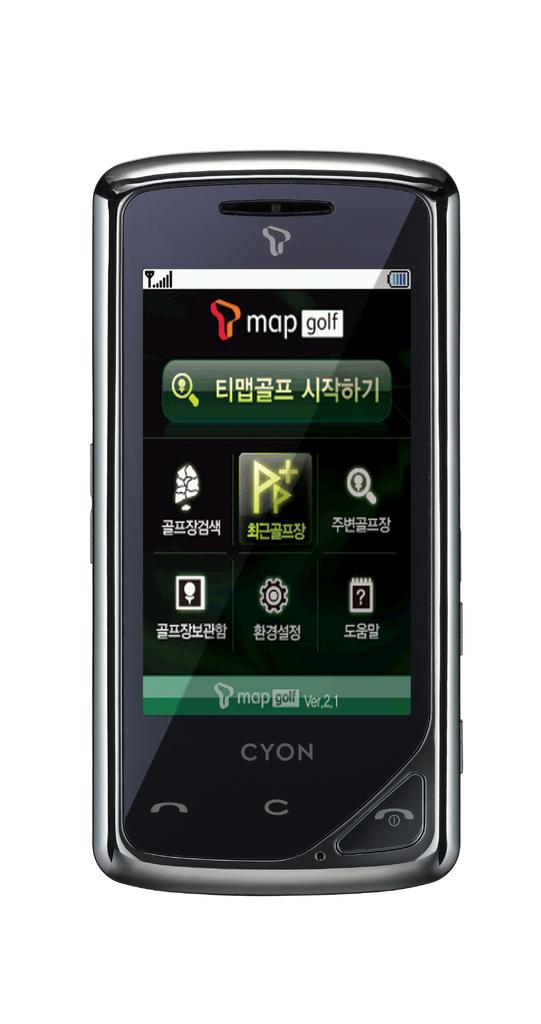What phone brand is this?
Provide a short and direct response. Cyon. What sport is named near the top of the phone screen?
Offer a very short reply. Golf. 